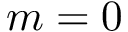Convert formula to latex. <formula><loc_0><loc_0><loc_500><loc_500>m = 0</formula> 